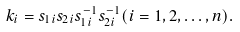<formula> <loc_0><loc_0><loc_500><loc_500>k _ { i } = s _ { 1 i } s _ { 2 i } s ^ { - 1 } _ { 1 i } s ^ { - 1 } _ { 2 i } ( i = 1 , 2 , \dots , n ) .</formula> 